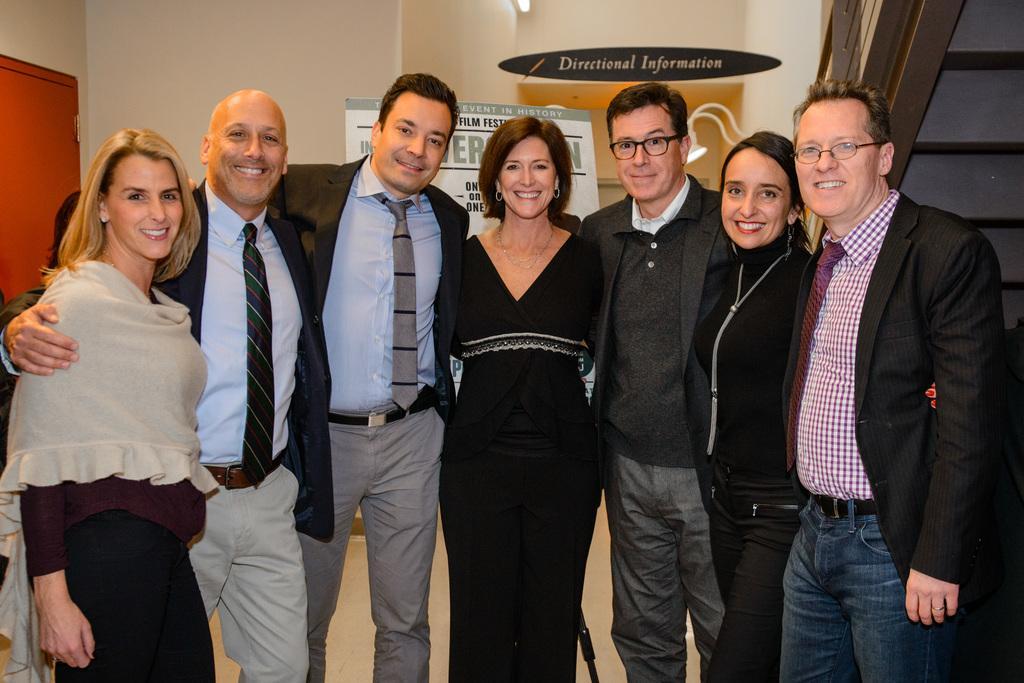Describe this image in one or two sentences. In this picture I can see group of people are standing together. Among them men are wearing black coats. These people are smiling. In the background I can see wall and boards. On the left side I can see a red color door. On the right side I can see stairs. 